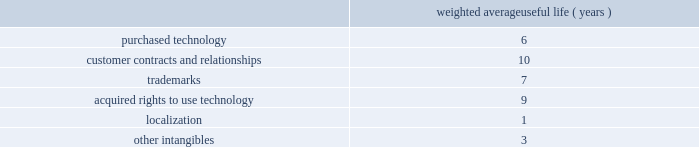Improvements are amortized using the straight-line method over the lesser of the remaining respective lease term or estimated useful lives ranging from 1 to 15 years .
Goodwill , purchased intangibles and other long-lived assets we review our goodwill for impairment annually , or more frequently , if facts and circumstances warrant a review .
We completed our annual impairment test in the second quarter of fiscal 2011 and determined that there was no impairment .
In the fourth quarter of fiscal 2011 , we announced changes to our business strategy which resulted in a reduction of forecasted revenue for certain of our products .
We performed an update to our goodwill impairment test for the enterprise reporting unit and determined there was no impairment .
Goodwill is assigned to one or more reporting segments on the date of acquisition .
We evaluate goodwill for impairment by comparing the fair value of each of our reporting segments to its carrying value , including the associated goodwill .
To determine the fair values , we use the market approach based on comparable publicly traded companies in similar lines of businesses and the income approach based on estimated discounted future cash flows .
Our cash flow assumptions consider historical and forecasted revenue , operating costs and other relevant factors .
We amortize intangible assets with finite lives over their estimated useful lives and review them for impairment whenever an impairment indicator exists .
We continually monitor events and changes in circumstances that could indicate carrying amounts of our long-lived assets , including our intangible assets may not be recoverable .
When such events or changes in circumstances occur , we assess recoverability by determining whether the carrying value of such assets will be recovered through the undiscounted expected future cash flows .
If the future undiscounted cash flows are less than the carrying amount of these assets , we recognize an impairment loss based on any excess of the carrying amount over the fair value of the assets .
We did not recognize any intangible asset impairment charges in fiscal 2011 , 2010 or 2009 .
Our intangible assets are amortized over their estimated useful lives of 1 to 13 years .
Amortization is based on the pattern in which the economic benefits of the intangible asset will be consumed .
The weighted average useful lives of our intangibles assets was as follows: .
Weighted average useful life ( years ) software development costs capitalization of software development costs for software to be sold , leased , or otherwise marketed begins upon the establishment of technological feasibility , which is generally the completion of a working prototype that has been certified as having no critical bugs and is a release candidate .
Amortization begins once the software is ready for its intended use , generally based on the pattern in which the economic benefits will be consumed .
To date , software development costs incurred between completion of a working prototype and general availability of the related product have not been material .
Internal use software we capitalize costs associated with customized internal-use software systems that have reached the application development stage .
Such capitalized costs include external direct costs utilized in developing or obtaining the applications and payroll and payroll-related expenses for employees , who are directly associated with the development of the applications .
Capitalization of such costs begins when the preliminary project stage is complete and ceases at the point in which the project is substantially complete and is ready for its intended purpose .
Table of contents adobe systems incorporated notes to consolidated financial statements ( continued ) .
What is the average yearly amortization rate related to trademarks? 
Computations: (100 / 7)
Answer: 14.28571. Improvements are amortized using the straight-line method over the lesser of the remaining respective lease term or estimated useful lives ranging from 1 to 15 years .
Goodwill , purchased intangibles and other long-lived assets we review our goodwill for impairment annually , or more frequently , if facts and circumstances warrant a review .
We completed our annual impairment test in the second quarter of fiscal 2011 and determined that there was no impairment .
In the fourth quarter of fiscal 2011 , we announced changes to our business strategy which resulted in a reduction of forecasted revenue for certain of our products .
We performed an update to our goodwill impairment test for the enterprise reporting unit and determined there was no impairment .
Goodwill is assigned to one or more reporting segments on the date of acquisition .
We evaluate goodwill for impairment by comparing the fair value of each of our reporting segments to its carrying value , including the associated goodwill .
To determine the fair values , we use the market approach based on comparable publicly traded companies in similar lines of businesses and the income approach based on estimated discounted future cash flows .
Our cash flow assumptions consider historical and forecasted revenue , operating costs and other relevant factors .
We amortize intangible assets with finite lives over their estimated useful lives and review them for impairment whenever an impairment indicator exists .
We continually monitor events and changes in circumstances that could indicate carrying amounts of our long-lived assets , including our intangible assets may not be recoverable .
When such events or changes in circumstances occur , we assess recoverability by determining whether the carrying value of such assets will be recovered through the undiscounted expected future cash flows .
If the future undiscounted cash flows are less than the carrying amount of these assets , we recognize an impairment loss based on any excess of the carrying amount over the fair value of the assets .
We did not recognize any intangible asset impairment charges in fiscal 2011 , 2010 or 2009 .
Our intangible assets are amortized over their estimated useful lives of 1 to 13 years .
Amortization is based on the pattern in which the economic benefits of the intangible asset will be consumed .
The weighted average useful lives of our intangibles assets was as follows: .
Weighted average useful life ( years ) software development costs capitalization of software development costs for software to be sold , leased , or otherwise marketed begins upon the establishment of technological feasibility , which is generally the completion of a working prototype that has been certified as having no critical bugs and is a release candidate .
Amortization begins once the software is ready for its intended use , generally based on the pattern in which the economic benefits will be consumed .
To date , software development costs incurred between completion of a working prototype and general availability of the related product have not been material .
Internal use software we capitalize costs associated with customized internal-use software systems that have reached the application development stage .
Such capitalized costs include external direct costs utilized in developing or obtaining the applications and payroll and payroll-related expenses for employees , who are directly associated with the development of the applications .
Capitalization of such costs begins when the preliminary project stage is complete and ceases at the point in which the project is substantially complete and is ready for its intended purpose .
Table of contents adobe systems incorporated notes to consolidated financial statements ( continued ) .
Was the weighted average useful life ( years ) of purchased technology greater than customer contracts and relationships? 
Computations: (6 > 10)
Answer: no. Improvements are amortized using the straight-line method over the lesser of the remaining respective lease term or estimated useful lives ranging from 1 to 15 years .
Goodwill , purchased intangibles and other long-lived assets we review our goodwill for impairment annually , or more frequently , if facts and circumstances warrant a review .
We completed our annual impairment test in the second quarter of fiscal 2011 and determined that there was no impairment .
In the fourth quarter of fiscal 2011 , we announced changes to our business strategy which resulted in a reduction of forecasted revenue for certain of our products .
We performed an update to our goodwill impairment test for the enterprise reporting unit and determined there was no impairment .
Goodwill is assigned to one or more reporting segments on the date of acquisition .
We evaluate goodwill for impairment by comparing the fair value of each of our reporting segments to its carrying value , including the associated goodwill .
To determine the fair values , we use the market approach based on comparable publicly traded companies in similar lines of businesses and the income approach based on estimated discounted future cash flows .
Our cash flow assumptions consider historical and forecasted revenue , operating costs and other relevant factors .
We amortize intangible assets with finite lives over their estimated useful lives and review them for impairment whenever an impairment indicator exists .
We continually monitor events and changes in circumstances that could indicate carrying amounts of our long-lived assets , including our intangible assets may not be recoverable .
When such events or changes in circumstances occur , we assess recoverability by determining whether the carrying value of such assets will be recovered through the undiscounted expected future cash flows .
If the future undiscounted cash flows are less than the carrying amount of these assets , we recognize an impairment loss based on any excess of the carrying amount over the fair value of the assets .
We did not recognize any intangible asset impairment charges in fiscal 2011 , 2010 or 2009 .
Our intangible assets are amortized over their estimated useful lives of 1 to 13 years .
Amortization is based on the pattern in which the economic benefits of the intangible asset will be consumed .
The weighted average useful lives of our intangibles assets was as follows: .
Weighted average useful life ( years ) software development costs capitalization of software development costs for software to be sold , leased , or otherwise marketed begins upon the establishment of technological feasibility , which is generally the completion of a working prototype that has been certified as having no critical bugs and is a release candidate .
Amortization begins once the software is ready for its intended use , generally based on the pattern in which the economic benefits will be consumed .
To date , software development costs incurred between completion of a working prototype and general availability of the related product have not been material .
Internal use software we capitalize costs associated with customized internal-use software systems that have reached the application development stage .
Such capitalized costs include external direct costs utilized in developing or obtaining the applications and payroll and payroll-related expenses for employees , who are directly associated with the development of the applications .
Capitalization of such costs begins when the preliminary project stage is complete and ceases at the point in which the project is substantially complete and is ready for its intended purpose .
Table of contents adobe systems incorporated notes to consolidated financial statements ( continued ) .
What is the average yearly amortization rate related to purchased technology? 
Computations: (100 / 6)
Answer: 16.66667. 